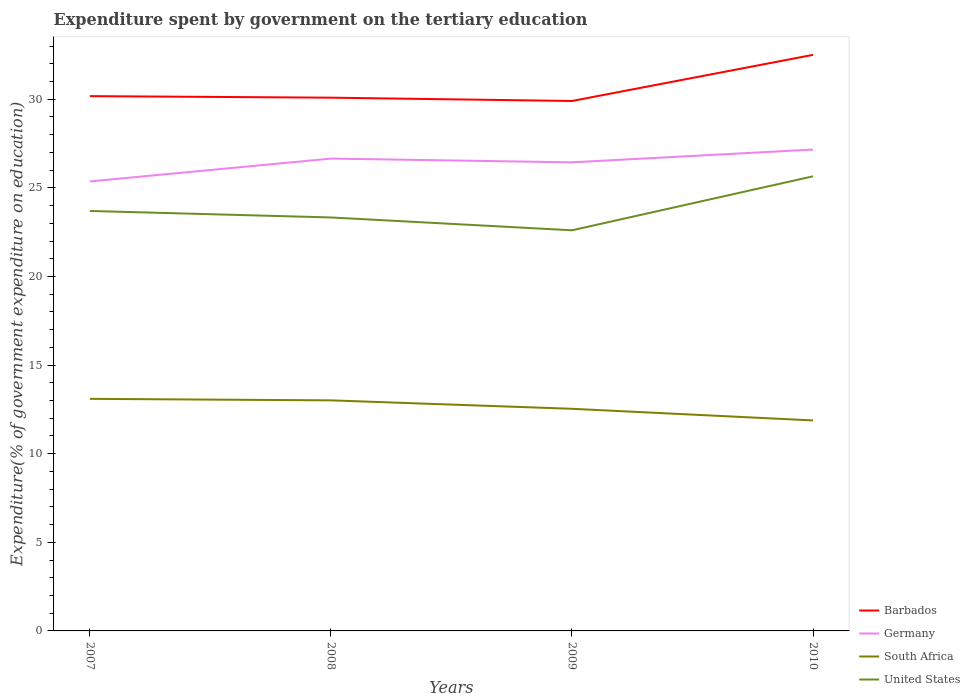How many different coloured lines are there?
Provide a succinct answer. 4. Across all years, what is the maximum expenditure spent by government on the tertiary education in Germany?
Your answer should be very brief. 25.36. What is the total expenditure spent by government on the tertiary education in United States in the graph?
Provide a succinct answer. -1.96. What is the difference between the highest and the second highest expenditure spent by government on the tertiary education in United States?
Ensure brevity in your answer.  3.05. What is the difference between the highest and the lowest expenditure spent by government on the tertiary education in South Africa?
Provide a short and direct response. 2. How many lines are there?
Give a very brief answer. 4. Does the graph contain any zero values?
Give a very brief answer. No. Does the graph contain grids?
Your answer should be very brief. No. Where does the legend appear in the graph?
Keep it short and to the point. Bottom right. How many legend labels are there?
Your answer should be compact. 4. What is the title of the graph?
Your answer should be very brief. Expenditure spent by government on the tertiary education. What is the label or title of the Y-axis?
Keep it short and to the point. Expenditure(% of government expenditure on education). What is the Expenditure(% of government expenditure on education) of Barbados in 2007?
Make the answer very short. 30.18. What is the Expenditure(% of government expenditure on education) in Germany in 2007?
Provide a short and direct response. 25.36. What is the Expenditure(% of government expenditure on education) in South Africa in 2007?
Offer a very short reply. 13.1. What is the Expenditure(% of government expenditure on education) in United States in 2007?
Your answer should be very brief. 23.7. What is the Expenditure(% of government expenditure on education) of Barbados in 2008?
Make the answer very short. 30.09. What is the Expenditure(% of government expenditure on education) in Germany in 2008?
Your answer should be compact. 26.65. What is the Expenditure(% of government expenditure on education) of South Africa in 2008?
Make the answer very short. 13.01. What is the Expenditure(% of government expenditure on education) of United States in 2008?
Give a very brief answer. 23.33. What is the Expenditure(% of government expenditure on education) in Barbados in 2009?
Your answer should be compact. 29.9. What is the Expenditure(% of government expenditure on education) in Germany in 2009?
Offer a very short reply. 26.44. What is the Expenditure(% of government expenditure on education) in South Africa in 2009?
Your response must be concise. 12.53. What is the Expenditure(% of government expenditure on education) in United States in 2009?
Ensure brevity in your answer.  22.61. What is the Expenditure(% of government expenditure on education) in Barbados in 2010?
Ensure brevity in your answer.  32.51. What is the Expenditure(% of government expenditure on education) in Germany in 2010?
Your answer should be compact. 27.16. What is the Expenditure(% of government expenditure on education) in South Africa in 2010?
Ensure brevity in your answer.  11.88. What is the Expenditure(% of government expenditure on education) of United States in 2010?
Your answer should be compact. 25.65. Across all years, what is the maximum Expenditure(% of government expenditure on education) in Barbados?
Keep it short and to the point. 32.51. Across all years, what is the maximum Expenditure(% of government expenditure on education) in Germany?
Keep it short and to the point. 27.16. Across all years, what is the maximum Expenditure(% of government expenditure on education) of South Africa?
Provide a succinct answer. 13.1. Across all years, what is the maximum Expenditure(% of government expenditure on education) in United States?
Make the answer very short. 25.65. Across all years, what is the minimum Expenditure(% of government expenditure on education) of Barbados?
Provide a short and direct response. 29.9. Across all years, what is the minimum Expenditure(% of government expenditure on education) in Germany?
Make the answer very short. 25.36. Across all years, what is the minimum Expenditure(% of government expenditure on education) in South Africa?
Offer a terse response. 11.88. Across all years, what is the minimum Expenditure(% of government expenditure on education) in United States?
Offer a very short reply. 22.61. What is the total Expenditure(% of government expenditure on education) in Barbados in the graph?
Make the answer very short. 122.67. What is the total Expenditure(% of government expenditure on education) in Germany in the graph?
Give a very brief answer. 105.62. What is the total Expenditure(% of government expenditure on education) in South Africa in the graph?
Provide a short and direct response. 50.52. What is the total Expenditure(% of government expenditure on education) in United States in the graph?
Give a very brief answer. 95.29. What is the difference between the Expenditure(% of government expenditure on education) of Barbados in 2007 and that in 2008?
Offer a very short reply. 0.09. What is the difference between the Expenditure(% of government expenditure on education) in Germany in 2007 and that in 2008?
Give a very brief answer. -1.29. What is the difference between the Expenditure(% of government expenditure on education) in South Africa in 2007 and that in 2008?
Offer a very short reply. 0.09. What is the difference between the Expenditure(% of government expenditure on education) of United States in 2007 and that in 2008?
Keep it short and to the point. 0.37. What is the difference between the Expenditure(% of government expenditure on education) in Barbados in 2007 and that in 2009?
Your answer should be compact. 0.27. What is the difference between the Expenditure(% of government expenditure on education) of Germany in 2007 and that in 2009?
Provide a short and direct response. -1.08. What is the difference between the Expenditure(% of government expenditure on education) of South Africa in 2007 and that in 2009?
Your answer should be very brief. 0.56. What is the difference between the Expenditure(% of government expenditure on education) in United States in 2007 and that in 2009?
Offer a terse response. 1.09. What is the difference between the Expenditure(% of government expenditure on education) of Barbados in 2007 and that in 2010?
Your answer should be very brief. -2.33. What is the difference between the Expenditure(% of government expenditure on education) in Germany in 2007 and that in 2010?
Your answer should be compact. -1.8. What is the difference between the Expenditure(% of government expenditure on education) in South Africa in 2007 and that in 2010?
Offer a very short reply. 1.22. What is the difference between the Expenditure(% of government expenditure on education) of United States in 2007 and that in 2010?
Keep it short and to the point. -1.96. What is the difference between the Expenditure(% of government expenditure on education) of Barbados in 2008 and that in 2009?
Provide a short and direct response. 0.19. What is the difference between the Expenditure(% of government expenditure on education) of Germany in 2008 and that in 2009?
Keep it short and to the point. 0.21. What is the difference between the Expenditure(% of government expenditure on education) in South Africa in 2008 and that in 2009?
Keep it short and to the point. 0.48. What is the difference between the Expenditure(% of government expenditure on education) in United States in 2008 and that in 2009?
Give a very brief answer. 0.72. What is the difference between the Expenditure(% of government expenditure on education) of Barbados in 2008 and that in 2010?
Keep it short and to the point. -2.42. What is the difference between the Expenditure(% of government expenditure on education) in Germany in 2008 and that in 2010?
Offer a terse response. -0.51. What is the difference between the Expenditure(% of government expenditure on education) in South Africa in 2008 and that in 2010?
Offer a terse response. 1.13. What is the difference between the Expenditure(% of government expenditure on education) in United States in 2008 and that in 2010?
Your response must be concise. -2.32. What is the difference between the Expenditure(% of government expenditure on education) in Barbados in 2009 and that in 2010?
Your answer should be very brief. -2.6. What is the difference between the Expenditure(% of government expenditure on education) of Germany in 2009 and that in 2010?
Provide a short and direct response. -0.72. What is the difference between the Expenditure(% of government expenditure on education) in South Africa in 2009 and that in 2010?
Give a very brief answer. 0.66. What is the difference between the Expenditure(% of government expenditure on education) of United States in 2009 and that in 2010?
Your answer should be compact. -3.05. What is the difference between the Expenditure(% of government expenditure on education) in Barbados in 2007 and the Expenditure(% of government expenditure on education) in Germany in 2008?
Offer a very short reply. 3.52. What is the difference between the Expenditure(% of government expenditure on education) in Barbados in 2007 and the Expenditure(% of government expenditure on education) in South Africa in 2008?
Make the answer very short. 17.17. What is the difference between the Expenditure(% of government expenditure on education) of Barbados in 2007 and the Expenditure(% of government expenditure on education) of United States in 2008?
Your response must be concise. 6.85. What is the difference between the Expenditure(% of government expenditure on education) in Germany in 2007 and the Expenditure(% of government expenditure on education) in South Africa in 2008?
Your answer should be compact. 12.35. What is the difference between the Expenditure(% of government expenditure on education) of Germany in 2007 and the Expenditure(% of government expenditure on education) of United States in 2008?
Keep it short and to the point. 2.03. What is the difference between the Expenditure(% of government expenditure on education) in South Africa in 2007 and the Expenditure(% of government expenditure on education) in United States in 2008?
Your answer should be compact. -10.24. What is the difference between the Expenditure(% of government expenditure on education) in Barbados in 2007 and the Expenditure(% of government expenditure on education) in Germany in 2009?
Your response must be concise. 3.73. What is the difference between the Expenditure(% of government expenditure on education) of Barbados in 2007 and the Expenditure(% of government expenditure on education) of South Africa in 2009?
Offer a very short reply. 17.64. What is the difference between the Expenditure(% of government expenditure on education) in Barbados in 2007 and the Expenditure(% of government expenditure on education) in United States in 2009?
Offer a very short reply. 7.57. What is the difference between the Expenditure(% of government expenditure on education) in Germany in 2007 and the Expenditure(% of government expenditure on education) in South Africa in 2009?
Offer a very short reply. 12.83. What is the difference between the Expenditure(% of government expenditure on education) in Germany in 2007 and the Expenditure(% of government expenditure on education) in United States in 2009?
Your answer should be very brief. 2.76. What is the difference between the Expenditure(% of government expenditure on education) in South Africa in 2007 and the Expenditure(% of government expenditure on education) in United States in 2009?
Your response must be concise. -9.51. What is the difference between the Expenditure(% of government expenditure on education) of Barbados in 2007 and the Expenditure(% of government expenditure on education) of Germany in 2010?
Offer a very short reply. 3.01. What is the difference between the Expenditure(% of government expenditure on education) of Barbados in 2007 and the Expenditure(% of government expenditure on education) of South Africa in 2010?
Your answer should be compact. 18.3. What is the difference between the Expenditure(% of government expenditure on education) in Barbados in 2007 and the Expenditure(% of government expenditure on education) in United States in 2010?
Provide a short and direct response. 4.52. What is the difference between the Expenditure(% of government expenditure on education) of Germany in 2007 and the Expenditure(% of government expenditure on education) of South Africa in 2010?
Keep it short and to the point. 13.49. What is the difference between the Expenditure(% of government expenditure on education) in Germany in 2007 and the Expenditure(% of government expenditure on education) in United States in 2010?
Keep it short and to the point. -0.29. What is the difference between the Expenditure(% of government expenditure on education) of South Africa in 2007 and the Expenditure(% of government expenditure on education) of United States in 2010?
Make the answer very short. -12.56. What is the difference between the Expenditure(% of government expenditure on education) of Barbados in 2008 and the Expenditure(% of government expenditure on education) of Germany in 2009?
Provide a succinct answer. 3.65. What is the difference between the Expenditure(% of government expenditure on education) in Barbados in 2008 and the Expenditure(% of government expenditure on education) in South Africa in 2009?
Your answer should be compact. 17.56. What is the difference between the Expenditure(% of government expenditure on education) in Barbados in 2008 and the Expenditure(% of government expenditure on education) in United States in 2009?
Give a very brief answer. 7.48. What is the difference between the Expenditure(% of government expenditure on education) in Germany in 2008 and the Expenditure(% of government expenditure on education) in South Africa in 2009?
Your answer should be very brief. 14.12. What is the difference between the Expenditure(% of government expenditure on education) in Germany in 2008 and the Expenditure(% of government expenditure on education) in United States in 2009?
Give a very brief answer. 4.05. What is the difference between the Expenditure(% of government expenditure on education) of South Africa in 2008 and the Expenditure(% of government expenditure on education) of United States in 2009?
Keep it short and to the point. -9.6. What is the difference between the Expenditure(% of government expenditure on education) of Barbados in 2008 and the Expenditure(% of government expenditure on education) of Germany in 2010?
Ensure brevity in your answer.  2.93. What is the difference between the Expenditure(% of government expenditure on education) in Barbados in 2008 and the Expenditure(% of government expenditure on education) in South Africa in 2010?
Offer a terse response. 18.21. What is the difference between the Expenditure(% of government expenditure on education) in Barbados in 2008 and the Expenditure(% of government expenditure on education) in United States in 2010?
Your response must be concise. 4.44. What is the difference between the Expenditure(% of government expenditure on education) in Germany in 2008 and the Expenditure(% of government expenditure on education) in South Africa in 2010?
Your answer should be compact. 14.78. What is the difference between the Expenditure(% of government expenditure on education) in South Africa in 2008 and the Expenditure(% of government expenditure on education) in United States in 2010?
Offer a very short reply. -12.64. What is the difference between the Expenditure(% of government expenditure on education) in Barbados in 2009 and the Expenditure(% of government expenditure on education) in Germany in 2010?
Your answer should be compact. 2.74. What is the difference between the Expenditure(% of government expenditure on education) in Barbados in 2009 and the Expenditure(% of government expenditure on education) in South Africa in 2010?
Provide a short and direct response. 18.03. What is the difference between the Expenditure(% of government expenditure on education) of Barbados in 2009 and the Expenditure(% of government expenditure on education) of United States in 2010?
Make the answer very short. 4.25. What is the difference between the Expenditure(% of government expenditure on education) in Germany in 2009 and the Expenditure(% of government expenditure on education) in South Africa in 2010?
Provide a short and direct response. 14.56. What is the difference between the Expenditure(% of government expenditure on education) in Germany in 2009 and the Expenditure(% of government expenditure on education) in United States in 2010?
Keep it short and to the point. 0.79. What is the difference between the Expenditure(% of government expenditure on education) of South Africa in 2009 and the Expenditure(% of government expenditure on education) of United States in 2010?
Make the answer very short. -13.12. What is the average Expenditure(% of government expenditure on education) of Barbados per year?
Your response must be concise. 30.67. What is the average Expenditure(% of government expenditure on education) in Germany per year?
Your response must be concise. 26.41. What is the average Expenditure(% of government expenditure on education) of South Africa per year?
Keep it short and to the point. 12.63. What is the average Expenditure(% of government expenditure on education) of United States per year?
Your answer should be compact. 23.82. In the year 2007, what is the difference between the Expenditure(% of government expenditure on education) of Barbados and Expenditure(% of government expenditure on education) of Germany?
Provide a short and direct response. 4.81. In the year 2007, what is the difference between the Expenditure(% of government expenditure on education) in Barbados and Expenditure(% of government expenditure on education) in South Africa?
Your answer should be compact. 17.08. In the year 2007, what is the difference between the Expenditure(% of government expenditure on education) in Barbados and Expenditure(% of government expenditure on education) in United States?
Offer a very short reply. 6.48. In the year 2007, what is the difference between the Expenditure(% of government expenditure on education) of Germany and Expenditure(% of government expenditure on education) of South Africa?
Provide a succinct answer. 12.27. In the year 2007, what is the difference between the Expenditure(% of government expenditure on education) of Germany and Expenditure(% of government expenditure on education) of United States?
Ensure brevity in your answer.  1.67. In the year 2007, what is the difference between the Expenditure(% of government expenditure on education) in South Africa and Expenditure(% of government expenditure on education) in United States?
Offer a terse response. -10.6. In the year 2008, what is the difference between the Expenditure(% of government expenditure on education) in Barbados and Expenditure(% of government expenditure on education) in Germany?
Offer a terse response. 3.44. In the year 2008, what is the difference between the Expenditure(% of government expenditure on education) in Barbados and Expenditure(% of government expenditure on education) in South Africa?
Keep it short and to the point. 17.08. In the year 2008, what is the difference between the Expenditure(% of government expenditure on education) in Barbados and Expenditure(% of government expenditure on education) in United States?
Provide a short and direct response. 6.76. In the year 2008, what is the difference between the Expenditure(% of government expenditure on education) of Germany and Expenditure(% of government expenditure on education) of South Africa?
Keep it short and to the point. 13.64. In the year 2008, what is the difference between the Expenditure(% of government expenditure on education) in Germany and Expenditure(% of government expenditure on education) in United States?
Provide a short and direct response. 3.32. In the year 2008, what is the difference between the Expenditure(% of government expenditure on education) of South Africa and Expenditure(% of government expenditure on education) of United States?
Your answer should be compact. -10.32. In the year 2009, what is the difference between the Expenditure(% of government expenditure on education) of Barbados and Expenditure(% of government expenditure on education) of Germany?
Your answer should be very brief. 3.46. In the year 2009, what is the difference between the Expenditure(% of government expenditure on education) in Barbados and Expenditure(% of government expenditure on education) in South Africa?
Offer a terse response. 17.37. In the year 2009, what is the difference between the Expenditure(% of government expenditure on education) in Barbados and Expenditure(% of government expenditure on education) in United States?
Provide a succinct answer. 7.3. In the year 2009, what is the difference between the Expenditure(% of government expenditure on education) of Germany and Expenditure(% of government expenditure on education) of South Africa?
Your response must be concise. 13.91. In the year 2009, what is the difference between the Expenditure(% of government expenditure on education) of Germany and Expenditure(% of government expenditure on education) of United States?
Offer a very short reply. 3.84. In the year 2009, what is the difference between the Expenditure(% of government expenditure on education) in South Africa and Expenditure(% of government expenditure on education) in United States?
Offer a very short reply. -10.07. In the year 2010, what is the difference between the Expenditure(% of government expenditure on education) of Barbados and Expenditure(% of government expenditure on education) of Germany?
Give a very brief answer. 5.34. In the year 2010, what is the difference between the Expenditure(% of government expenditure on education) of Barbados and Expenditure(% of government expenditure on education) of South Africa?
Offer a terse response. 20.63. In the year 2010, what is the difference between the Expenditure(% of government expenditure on education) of Barbados and Expenditure(% of government expenditure on education) of United States?
Ensure brevity in your answer.  6.85. In the year 2010, what is the difference between the Expenditure(% of government expenditure on education) in Germany and Expenditure(% of government expenditure on education) in South Africa?
Keep it short and to the point. 15.29. In the year 2010, what is the difference between the Expenditure(% of government expenditure on education) of Germany and Expenditure(% of government expenditure on education) of United States?
Your answer should be compact. 1.51. In the year 2010, what is the difference between the Expenditure(% of government expenditure on education) of South Africa and Expenditure(% of government expenditure on education) of United States?
Provide a succinct answer. -13.78. What is the ratio of the Expenditure(% of government expenditure on education) in Germany in 2007 to that in 2008?
Offer a terse response. 0.95. What is the ratio of the Expenditure(% of government expenditure on education) in South Africa in 2007 to that in 2008?
Your answer should be very brief. 1.01. What is the ratio of the Expenditure(% of government expenditure on education) in United States in 2007 to that in 2008?
Your response must be concise. 1.02. What is the ratio of the Expenditure(% of government expenditure on education) of Barbados in 2007 to that in 2009?
Provide a succinct answer. 1.01. What is the ratio of the Expenditure(% of government expenditure on education) of Germany in 2007 to that in 2009?
Offer a very short reply. 0.96. What is the ratio of the Expenditure(% of government expenditure on education) in South Africa in 2007 to that in 2009?
Provide a short and direct response. 1.04. What is the ratio of the Expenditure(% of government expenditure on education) of United States in 2007 to that in 2009?
Your response must be concise. 1.05. What is the ratio of the Expenditure(% of government expenditure on education) of Barbados in 2007 to that in 2010?
Offer a very short reply. 0.93. What is the ratio of the Expenditure(% of government expenditure on education) of Germany in 2007 to that in 2010?
Ensure brevity in your answer.  0.93. What is the ratio of the Expenditure(% of government expenditure on education) in South Africa in 2007 to that in 2010?
Keep it short and to the point. 1.1. What is the ratio of the Expenditure(% of government expenditure on education) of United States in 2007 to that in 2010?
Ensure brevity in your answer.  0.92. What is the ratio of the Expenditure(% of government expenditure on education) of Barbados in 2008 to that in 2009?
Keep it short and to the point. 1.01. What is the ratio of the Expenditure(% of government expenditure on education) of South Africa in 2008 to that in 2009?
Your answer should be compact. 1.04. What is the ratio of the Expenditure(% of government expenditure on education) of United States in 2008 to that in 2009?
Ensure brevity in your answer.  1.03. What is the ratio of the Expenditure(% of government expenditure on education) of Barbados in 2008 to that in 2010?
Your response must be concise. 0.93. What is the ratio of the Expenditure(% of government expenditure on education) of Germany in 2008 to that in 2010?
Provide a short and direct response. 0.98. What is the ratio of the Expenditure(% of government expenditure on education) in South Africa in 2008 to that in 2010?
Provide a succinct answer. 1.1. What is the ratio of the Expenditure(% of government expenditure on education) of United States in 2008 to that in 2010?
Make the answer very short. 0.91. What is the ratio of the Expenditure(% of government expenditure on education) of Barbados in 2009 to that in 2010?
Offer a terse response. 0.92. What is the ratio of the Expenditure(% of government expenditure on education) in Germany in 2009 to that in 2010?
Provide a succinct answer. 0.97. What is the ratio of the Expenditure(% of government expenditure on education) in South Africa in 2009 to that in 2010?
Offer a terse response. 1.06. What is the ratio of the Expenditure(% of government expenditure on education) in United States in 2009 to that in 2010?
Ensure brevity in your answer.  0.88. What is the difference between the highest and the second highest Expenditure(% of government expenditure on education) in Barbados?
Your answer should be compact. 2.33. What is the difference between the highest and the second highest Expenditure(% of government expenditure on education) of Germany?
Ensure brevity in your answer.  0.51. What is the difference between the highest and the second highest Expenditure(% of government expenditure on education) in South Africa?
Provide a short and direct response. 0.09. What is the difference between the highest and the second highest Expenditure(% of government expenditure on education) in United States?
Ensure brevity in your answer.  1.96. What is the difference between the highest and the lowest Expenditure(% of government expenditure on education) in Barbados?
Your answer should be very brief. 2.6. What is the difference between the highest and the lowest Expenditure(% of government expenditure on education) of Germany?
Make the answer very short. 1.8. What is the difference between the highest and the lowest Expenditure(% of government expenditure on education) of South Africa?
Provide a short and direct response. 1.22. What is the difference between the highest and the lowest Expenditure(% of government expenditure on education) of United States?
Make the answer very short. 3.05. 